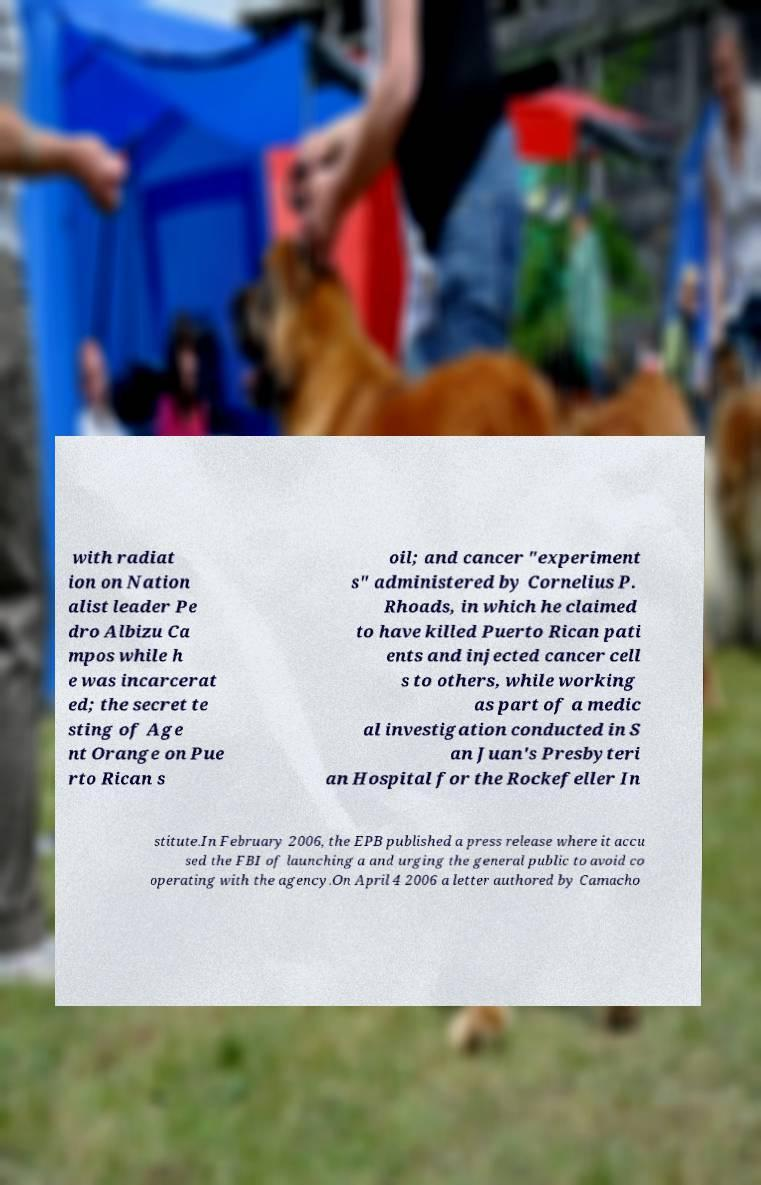Can you read and provide the text displayed in the image?This photo seems to have some interesting text. Can you extract and type it out for me? with radiat ion on Nation alist leader Pe dro Albizu Ca mpos while h e was incarcerat ed; the secret te sting of Age nt Orange on Pue rto Rican s oil; and cancer "experiment s" administered by Cornelius P. Rhoads, in which he claimed to have killed Puerto Rican pati ents and injected cancer cell s to others, while working as part of a medic al investigation conducted in S an Juan's Presbyteri an Hospital for the Rockefeller In stitute.In February 2006, the EPB published a press release where it accu sed the FBI of launching a and urging the general public to avoid co operating with the agency.On April 4 2006 a letter authored by Camacho 